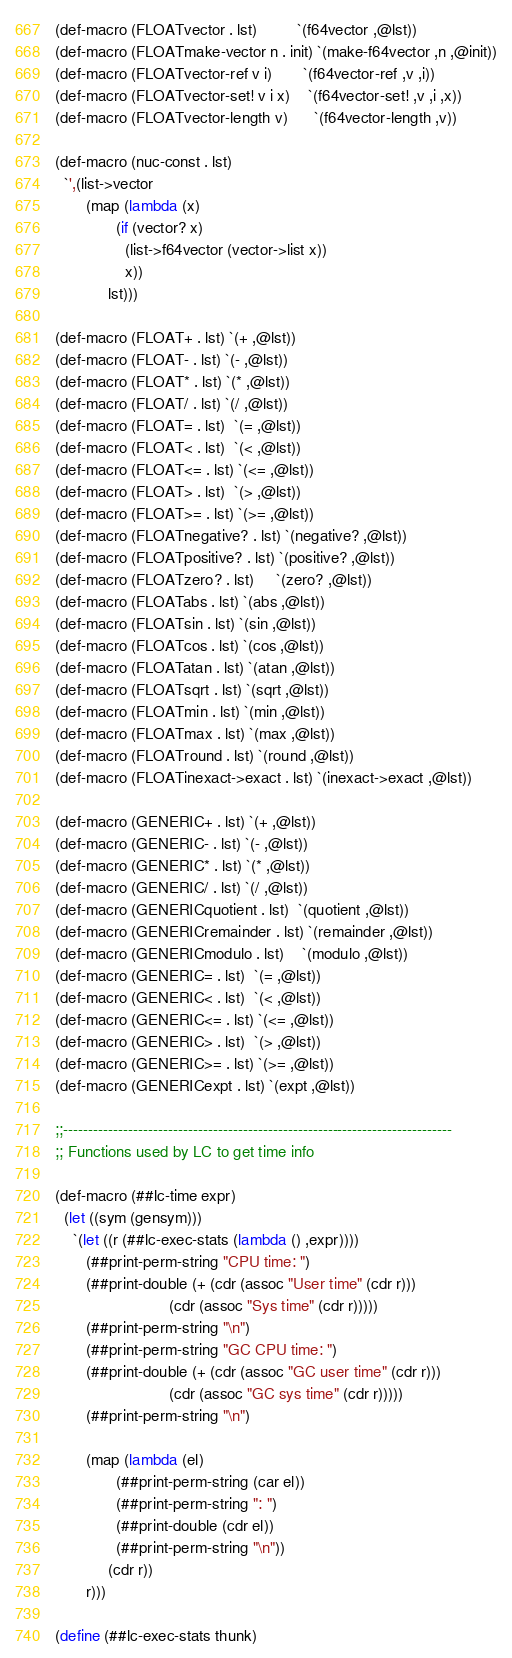Convert code to text. <code><loc_0><loc_0><loc_500><loc_500><_Scheme_>(def-macro (FLOATvector . lst)         `(f64vector ,@lst))
(def-macro (FLOATmake-vector n . init) `(make-f64vector ,n ,@init))
(def-macro (FLOATvector-ref v i)       `(f64vector-ref ,v ,i))
(def-macro (FLOATvector-set! v i x)    `(f64vector-set! ,v ,i ,x))
(def-macro (FLOATvector-length v)      `(f64vector-length ,v))

(def-macro (nuc-const . lst)
  `',(list->vector
       (map (lambda (x)
              (if (vector? x)
                (list->f64vector (vector->list x))
                x))
            lst)))

(def-macro (FLOAT+ . lst) `(+ ,@lst))
(def-macro (FLOAT- . lst) `(- ,@lst))
(def-macro (FLOAT* . lst) `(* ,@lst))
(def-macro (FLOAT/ . lst) `(/ ,@lst))
(def-macro (FLOAT= . lst)  `(= ,@lst))
(def-macro (FLOAT< . lst)  `(< ,@lst))
(def-macro (FLOAT<= . lst) `(<= ,@lst))
(def-macro (FLOAT> . lst)  `(> ,@lst))
(def-macro (FLOAT>= . lst) `(>= ,@lst))
(def-macro (FLOATnegative? . lst) `(negative? ,@lst))
(def-macro (FLOATpositive? . lst) `(positive? ,@lst))
(def-macro (FLOATzero? . lst)     `(zero? ,@lst))
(def-macro (FLOATabs . lst) `(abs ,@lst))
(def-macro (FLOATsin . lst) `(sin ,@lst))
(def-macro (FLOATcos . lst) `(cos ,@lst))
(def-macro (FLOATatan . lst) `(atan ,@lst))
(def-macro (FLOATsqrt . lst) `(sqrt ,@lst))
(def-macro (FLOATmin . lst) `(min ,@lst))
(def-macro (FLOATmax . lst) `(max ,@lst))
(def-macro (FLOATround . lst) `(round ,@lst))
(def-macro (FLOATinexact->exact . lst) `(inexact->exact ,@lst))

(def-macro (GENERIC+ . lst) `(+ ,@lst))
(def-macro (GENERIC- . lst) `(- ,@lst))
(def-macro (GENERIC* . lst) `(* ,@lst))
(def-macro (GENERIC/ . lst) `(/ ,@lst))
(def-macro (GENERICquotient . lst)  `(quotient ,@lst))
(def-macro (GENERICremainder . lst) `(remainder ,@lst))
(def-macro (GENERICmodulo . lst)    `(modulo ,@lst))
(def-macro (GENERIC= . lst)  `(= ,@lst))
(def-macro (GENERIC< . lst)  `(< ,@lst))
(def-macro (GENERIC<= . lst) `(<= ,@lst))
(def-macro (GENERIC> . lst)  `(> ,@lst))
(def-macro (GENERIC>= . lst) `(>= ,@lst))
(def-macro (GENERICexpt . lst) `(expt ,@lst))

;;------------------------------------------------------------------------------
;; Functions used by LC to get time info

(def-macro (##lc-time expr)
  (let ((sym (gensym)))
    `(let ((r (##lc-exec-stats (lambda () ,expr))))
       (##print-perm-string "CPU time: ")
       (##print-double (+ (cdr (assoc "User time" (cdr r)))
                          (cdr (assoc "Sys time" (cdr r)))))
       (##print-perm-string "\n")
       (##print-perm-string "GC CPU time: ")
       (##print-double (+ (cdr (assoc "GC user time" (cdr r)))
                          (cdr (assoc "GC sys time" (cdr r)))))
       (##print-perm-string "\n")

       (map (lambda (el)
              (##print-perm-string (car el))
              (##print-perm-string ": ")
              (##print-double (cdr el))
              (##print-perm-string "\n"))
            (cdr r))
       r)))

(define (##lc-exec-stats thunk)</code> 